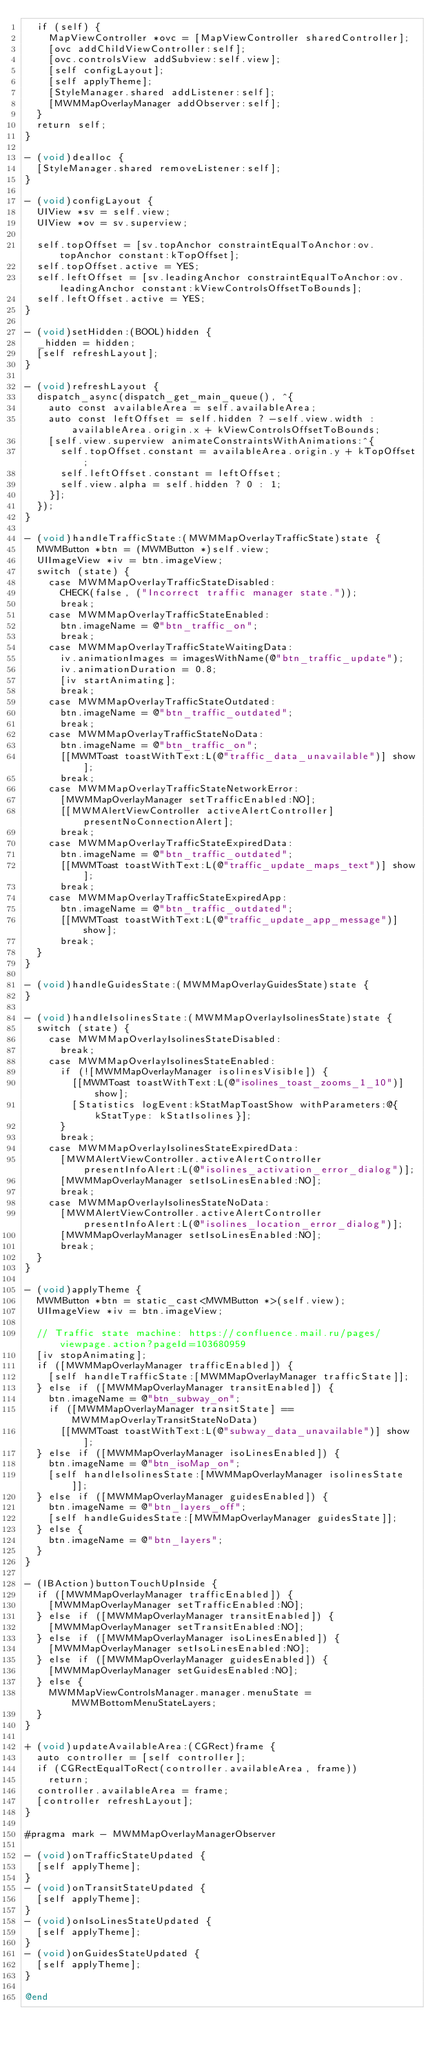Convert code to text. <code><loc_0><loc_0><loc_500><loc_500><_ObjectiveC_>  if (self) {
    MapViewController *ovc = [MapViewController sharedController];
    [ovc addChildViewController:self];
    [ovc.controlsView addSubview:self.view];
    [self configLayout];
    [self applyTheme];
    [StyleManager.shared addListener:self];
    [MWMMapOverlayManager addObserver:self];
  }
  return self;
}

- (void)dealloc {
  [StyleManager.shared removeListener:self];
}

- (void)configLayout {
  UIView *sv = self.view;
  UIView *ov = sv.superview;

  self.topOffset = [sv.topAnchor constraintEqualToAnchor:ov.topAnchor constant:kTopOffset];
  self.topOffset.active = YES;
  self.leftOffset = [sv.leadingAnchor constraintEqualToAnchor:ov.leadingAnchor constant:kViewControlsOffsetToBounds];
  self.leftOffset.active = YES;
}

- (void)setHidden:(BOOL)hidden {
  _hidden = hidden;
  [self refreshLayout];
}

- (void)refreshLayout {
  dispatch_async(dispatch_get_main_queue(), ^{
    auto const availableArea = self.availableArea;
    auto const leftOffset = self.hidden ? -self.view.width : availableArea.origin.x + kViewControlsOffsetToBounds;
    [self.view.superview animateConstraintsWithAnimations:^{
      self.topOffset.constant = availableArea.origin.y + kTopOffset;
      self.leftOffset.constant = leftOffset;
      self.view.alpha = self.hidden ? 0 : 1;
    }];
  });
}

- (void)handleTrafficState:(MWMMapOverlayTrafficState)state {
  MWMButton *btn = (MWMButton *)self.view;
  UIImageView *iv = btn.imageView;
  switch (state) {
    case MWMMapOverlayTrafficStateDisabled:
      CHECK(false, ("Incorrect traffic manager state."));
      break;
    case MWMMapOverlayTrafficStateEnabled:
      btn.imageName = @"btn_traffic_on";
      break;
    case MWMMapOverlayTrafficStateWaitingData:
      iv.animationImages = imagesWithName(@"btn_traffic_update");
      iv.animationDuration = 0.8;
      [iv startAnimating];
      break;
    case MWMMapOverlayTrafficStateOutdated:
      btn.imageName = @"btn_traffic_outdated";
      break;
    case MWMMapOverlayTrafficStateNoData:
      btn.imageName = @"btn_traffic_on";
      [[MWMToast toastWithText:L(@"traffic_data_unavailable")] show];
      break;
    case MWMMapOverlayTrafficStateNetworkError:
      [MWMMapOverlayManager setTrafficEnabled:NO];
      [[MWMAlertViewController activeAlertController] presentNoConnectionAlert];
      break;
    case MWMMapOverlayTrafficStateExpiredData:
      btn.imageName = @"btn_traffic_outdated";
      [[MWMToast toastWithText:L(@"traffic_update_maps_text")] show];
      break;
    case MWMMapOverlayTrafficStateExpiredApp:
      btn.imageName = @"btn_traffic_outdated";
      [[MWMToast toastWithText:L(@"traffic_update_app_message")] show];
      break;
  }
}

- (void)handleGuidesState:(MWMMapOverlayGuidesState)state {
}

- (void)handleIsolinesState:(MWMMapOverlayIsolinesState)state {
  switch (state) {
    case MWMMapOverlayIsolinesStateDisabled:
      break;
    case MWMMapOverlayIsolinesStateEnabled:
      if (![MWMMapOverlayManager isolinesVisible]) {
        [[MWMToast toastWithText:L(@"isolines_toast_zooms_1_10")] show];
        [Statistics logEvent:kStatMapToastShow withParameters:@{kStatType: kStatIsolines}];
      }
      break;
    case MWMMapOverlayIsolinesStateExpiredData:
      [MWMAlertViewController.activeAlertController presentInfoAlert:L(@"isolines_activation_error_dialog")];
      [MWMMapOverlayManager setIsoLinesEnabled:NO];
      break;
    case MWMMapOverlayIsolinesStateNoData:
      [MWMAlertViewController.activeAlertController presentInfoAlert:L(@"isolines_location_error_dialog")];
      [MWMMapOverlayManager setIsoLinesEnabled:NO];
      break;
  }
}

- (void)applyTheme {
  MWMButton *btn = static_cast<MWMButton *>(self.view);
  UIImageView *iv = btn.imageView;

  // Traffic state machine: https://confluence.mail.ru/pages/viewpage.action?pageId=103680959
  [iv stopAnimating];
  if ([MWMMapOverlayManager trafficEnabled]) {
    [self handleTrafficState:[MWMMapOverlayManager trafficState]];
  } else if ([MWMMapOverlayManager transitEnabled]) {
    btn.imageName = @"btn_subway_on";
    if ([MWMMapOverlayManager transitState] == MWMMapOverlayTransitStateNoData)
      [[MWMToast toastWithText:L(@"subway_data_unavailable")] show];
  } else if ([MWMMapOverlayManager isoLinesEnabled]) {
    btn.imageName = @"btn_isoMap_on";
    [self handleIsolinesState:[MWMMapOverlayManager isolinesState]];
  } else if ([MWMMapOverlayManager guidesEnabled]) {
    btn.imageName = @"btn_layers_off";
    [self handleGuidesState:[MWMMapOverlayManager guidesState]];
  } else {
    btn.imageName = @"btn_layers";
  }
}

- (IBAction)buttonTouchUpInside {
  if ([MWMMapOverlayManager trafficEnabled]) {
    [MWMMapOverlayManager setTrafficEnabled:NO];
  } else if ([MWMMapOverlayManager transitEnabled]) {
    [MWMMapOverlayManager setTransitEnabled:NO];
  } else if ([MWMMapOverlayManager isoLinesEnabled]) {
    [MWMMapOverlayManager setIsoLinesEnabled:NO];
  } else if ([MWMMapOverlayManager guidesEnabled]) {
    [MWMMapOverlayManager setGuidesEnabled:NO];
  } else {
    MWMMapViewControlsManager.manager.menuState = MWMBottomMenuStateLayers;
  }
}

+ (void)updateAvailableArea:(CGRect)frame {
  auto controller = [self controller];
  if (CGRectEqualToRect(controller.availableArea, frame))
    return;
  controller.availableArea = frame;
  [controller refreshLayout];
}

#pragma mark - MWMMapOverlayManagerObserver

- (void)onTrafficStateUpdated {
  [self applyTheme];
}
- (void)onTransitStateUpdated {
  [self applyTheme];
}
- (void)onIsoLinesStateUpdated {
  [self applyTheme];
}
- (void)onGuidesStateUpdated {
  [self applyTheme];
}

@end
</code> 